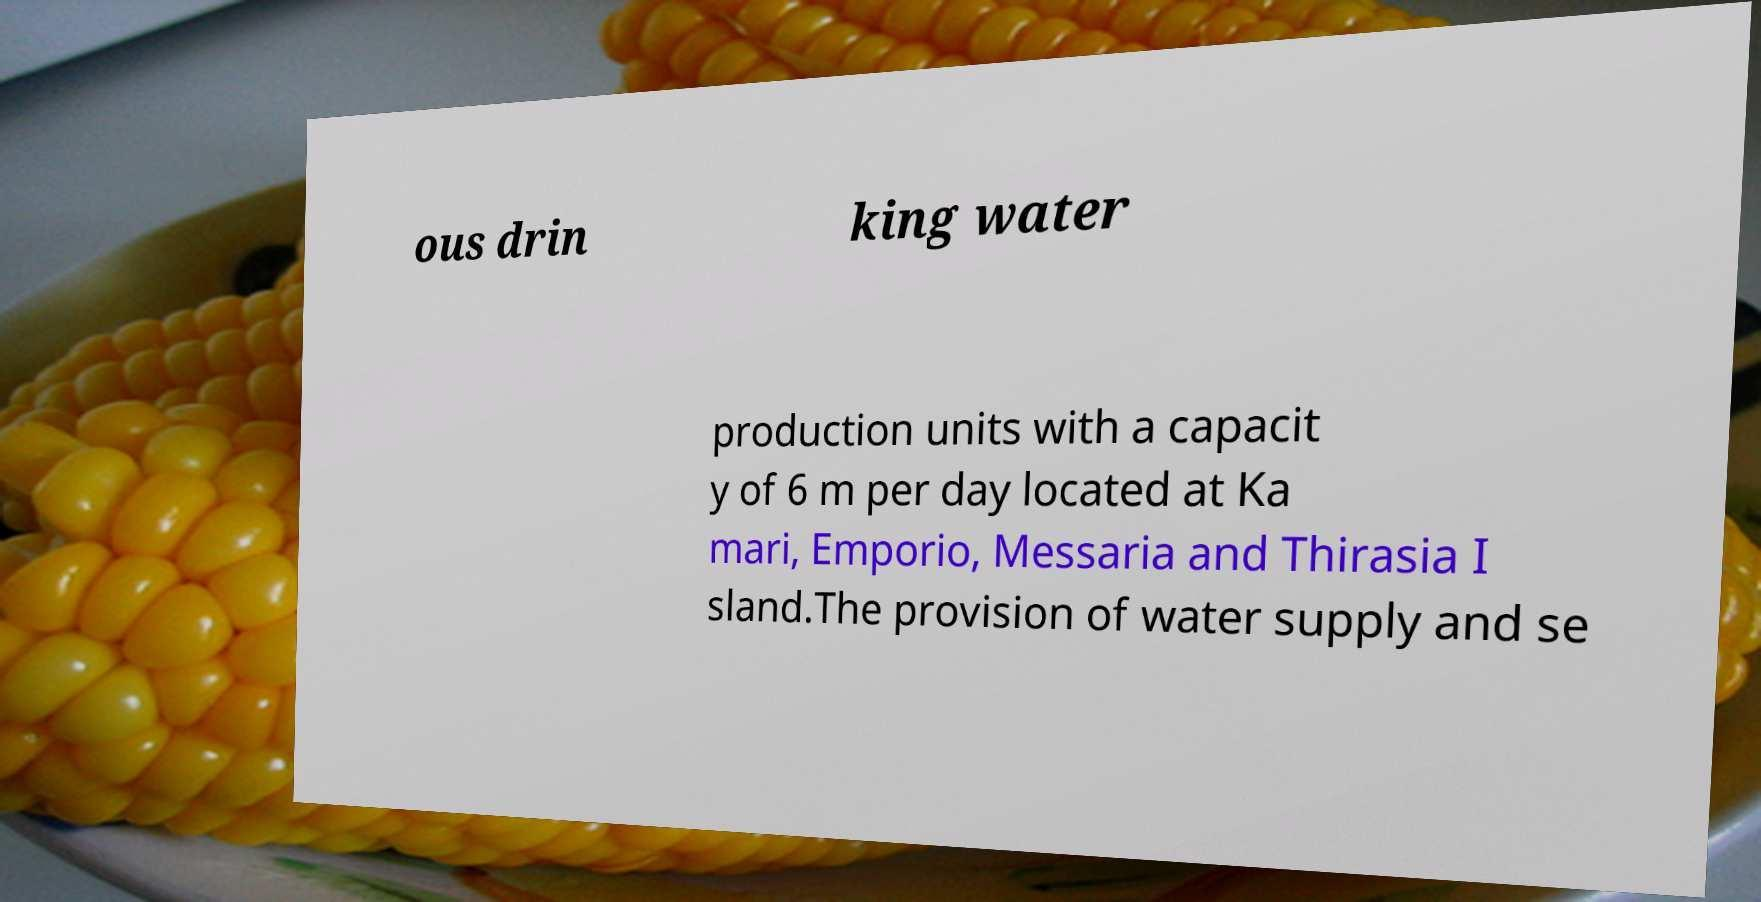Can you accurately transcribe the text from the provided image for me? ous drin king water production units with a capacit y of 6 m per day located at Ka mari, Emporio, Messaria and Thirasia I sland.The provision of water supply and se 